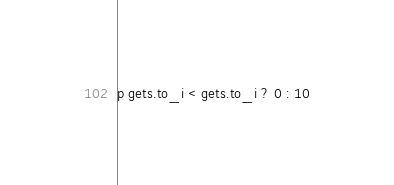Convert code to text. <code><loc_0><loc_0><loc_500><loc_500><_Ruby_>p gets.to_i < gets.to_i ? 0 : 10</code> 